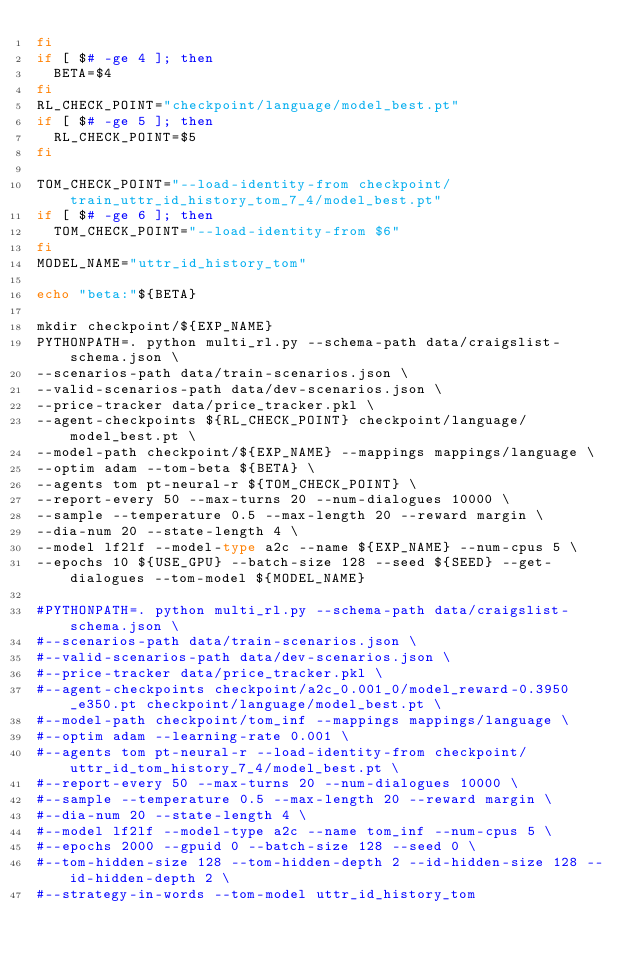Convert code to text. <code><loc_0><loc_0><loc_500><loc_500><_Bash_>fi
if [ $# -ge 4 ]; then
  BETA=$4
fi
RL_CHECK_POINT="checkpoint/language/model_best.pt"
if [ $# -ge 5 ]; then
  RL_CHECK_POINT=$5
fi

TOM_CHECK_POINT="--load-identity-from checkpoint/train_uttr_id_history_tom_7_4/model_best.pt"
if [ $# -ge 6 ]; then
  TOM_CHECK_POINT="--load-identity-from $6"
fi
MODEL_NAME="uttr_id_history_tom"

echo "beta:"${BETA}

mkdir checkpoint/${EXP_NAME}
PYTHONPATH=. python multi_rl.py --schema-path data/craigslist-schema.json \
--scenarios-path data/train-scenarios.json \
--valid-scenarios-path data/dev-scenarios.json \
--price-tracker data/price_tracker.pkl \
--agent-checkpoints ${RL_CHECK_POINT} checkpoint/language/model_best.pt \
--model-path checkpoint/${EXP_NAME} --mappings mappings/language \
--optim adam --tom-beta ${BETA} \
--agents tom pt-neural-r ${TOM_CHECK_POINT} \
--report-every 50 --max-turns 20 --num-dialogues 10000 \
--sample --temperature 0.5 --max-length 20 --reward margin \
--dia-num 20 --state-length 4 \
--model lf2lf --model-type a2c --name ${EXP_NAME} --num-cpus 5 \
--epochs 10 ${USE_GPU} --batch-size 128 --seed ${SEED} --get-dialogues --tom-model ${MODEL_NAME}

#PYTHONPATH=. python multi_rl.py --schema-path data/craigslist-schema.json \
#--scenarios-path data/train-scenarios.json \
#--valid-scenarios-path data/dev-scenarios.json \
#--price-tracker data/price_tracker.pkl \
#--agent-checkpoints checkpoint/a2c_0.001_0/model_reward-0.3950_e350.pt checkpoint/language/model_best.pt \
#--model-path checkpoint/tom_inf --mappings mappings/language \
#--optim adam --learning-rate 0.001 \
#--agents tom pt-neural-r --load-identity-from checkpoint/uttr_id_tom_history_7_4/model_best.pt \
#--report-every 50 --max-turns 20 --num-dialogues 10000 \
#--sample --temperature 0.5 --max-length 20 --reward margin \
#--dia-num 20 --state-length 4 \
#--model lf2lf --model-type a2c --name tom_inf --num-cpus 5 \
#--epochs 2000 --gpuid 0 --batch-size 128 --seed 0 \
#--tom-hidden-size 128 --tom-hidden-depth 2 --id-hidden-size 128 --id-hidden-depth 2 \
#--strategy-in-words --tom-model uttr_id_history_tom</code> 